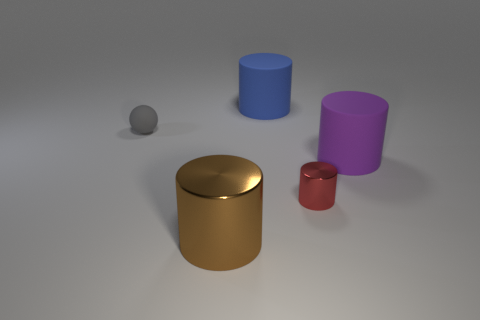Is there a large blue thing that is behind the cylinder that is behind the tiny object on the left side of the brown shiny cylinder?
Provide a short and direct response. No. There is a big blue thing right of the small gray object; what is it made of?
Your response must be concise. Rubber. Is the shape of the gray rubber thing the same as the metallic object that is on the right side of the brown cylinder?
Your answer should be compact. No. Is the number of tiny gray rubber spheres that are to the left of the tiny rubber object the same as the number of big brown metallic objects that are right of the big purple rubber object?
Offer a very short reply. Yes. How many other things are made of the same material as the red cylinder?
Your response must be concise. 1. How many metallic things are either large yellow things or blue things?
Provide a short and direct response. 0. There is a metal thing in front of the red object; is it the same shape as the small gray thing?
Make the answer very short. No. Is the number of small gray matte things that are behind the red metal object greater than the number of big red spheres?
Offer a terse response. Yes. What number of big rubber objects are both to the right of the large blue object and to the left of the purple rubber cylinder?
Offer a terse response. 0. The large rubber object behind the matte object on the right side of the red cylinder is what color?
Keep it short and to the point. Blue. 